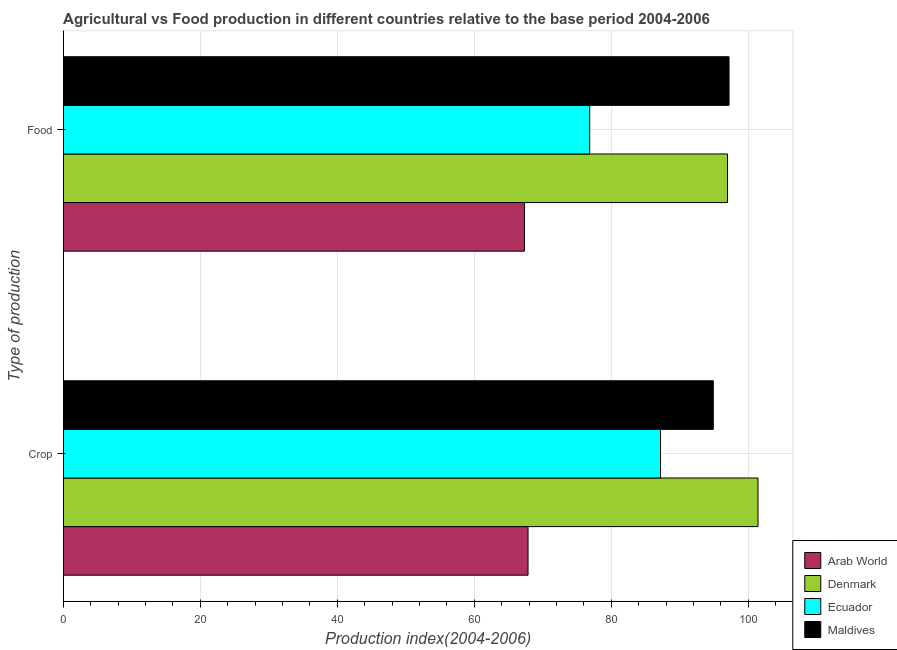Are the number of bars per tick equal to the number of legend labels?
Make the answer very short. Yes. How many bars are there on the 1st tick from the top?
Provide a succinct answer. 4. What is the label of the 2nd group of bars from the top?
Give a very brief answer. Crop. What is the crop production index in Ecuador?
Your answer should be compact. 87.18. Across all countries, what is the maximum crop production index?
Your answer should be very brief. 101.41. Across all countries, what is the minimum food production index?
Your answer should be very brief. 67.32. In which country was the food production index maximum?
Your answer should be very brief. Maldives. In which country was the crop production index minimum?
Provide a short and direct response. Arab World. What is the total food production index in the graph?
Offer a very short reply. 338.29. What is the difference between the crop production index in Arab World and that in Maldives?
Give a very brief answer. -27.04. What is the difference between the crop production index in Arab World and the food production index in Maldives?
Your answer should be compact. -29.34. What is the average crop production index per country?
Keep it short and to the point. 87.83. What is the difference between the crop production index and food production index in Denmark?
Make the answer very short. 4.46. What is the ratio of the food production index in Ecuador to that in Maldives?
Offer a very short reply. 0.79. Is the crop production index in Denmark less than that in Ecuador?
Make the answer very short. No. What does the 2nd bar from the top in Food represents?
Offer a very short reply. Ecuador. What does the 2nd bar from the bottom in Food represents?
Ensure brevity in your answer.  Denmark. How many bars are there?
Make the answer very short. 8. Are all the bars in the graph horizontal?
Your answer should be very brief. Yes. How many countries are there in the graph?
Your answer should be very brief. 4. What is the difference between two consecutive major ticks on the X-axis?
Offer a terse response. 20. Are the values on the major ticks of X-axis written in scientific E-notation?
Your answer should be compact. No. Does the graph contain any zero values?
Make the answer very short. No. How are the legend labels stacked?
Provide a short and direct response. Vertical. What is the title of the graph?
Give a very brief answer. Agricultural vs Food production in different countries relative to the base period 2004-2006. Does "Other small states" appear as one of the legend labels in the graph?
Keep it short and to the point. No. What is the label or title of the X-axis?
Offer a terse response. Production index(2004-2006). What is the label or title of the Y-axis?
Give a very brief answer. Type of production. What is the Production index(2004-2006) of Arab World in Crop?
Offer a terse response. 67.84. What is the Production index(2004-2006) of Denmark in Crop?
Keep it short and to the point. 101.41. What is the Production index(2004-2006) in Ecuador in Crop?
Keep it short and to the point. 87.18. What is the Production index(2004-2006) in Maldives in Crop?
Offer a terse response. 94.88. What is the Production index(2004-2006) of Arab World in Food?
Offer a terse response. 67.32. What is the Production index(2004-2006) in Denmark in Food?
Provide a succinct answer. 96.95. What is the Production index(2004-2006) of Ecuador in Food?
Ensure brevity in your answer.  76.84. What is the Production index(2004-2006) of Maldives in Food?
Your answer should be very brief. 97.18. Across all Type of production, what is the maximum Production index(2004-2006) of Arab World?
Your response must be concise. 67.84. Across all Type of production, what is the maximum Production index(2004-2006) of Denmark?
Ensure brevity in your answer.  101.41. Across all Type of production, what is the maximum Production index(2004-2006) in Ecuador?
Your answer should be very brief. 87.18. Across all Type of production, what is the maximum Production index(2004-2006) of Maldives?
Your response must be concise. 97.18. Across all Type of production, what is the minimum Production index(2004-2006) in Arab World?
Ensure brevity in your answer.  67.32. Across all Type of production, what is the minimum Production index(2004-2006) in Denmark?
Your answer should be very brief. 96.95. Across all Type of production, what is the minimum Production index(2004-2006) of Ecuador?
Your answer should be very brief. 76.84. Across all Type of production, what is the minimum Production index(2004-2006) of Maldives?
Ensure brevity in your answer.  94.88. What is the total Production index(2004-2006) of Arab World in the graph?
Give a very brief answer. 135.17. What is the total Production index(2004-2006) of Denmark in the graph?
Keep it short and to the point. 198.36. What is the total Production index(2004-2006) in Ecuador in the graph?
Your answer should be compact. 164.02. What is the total Production index(2004-2006) in Maldives in the graph?
Provide a succinct answer. 192.06. What is the difference between the Production index(2004-2006) in Arab World in Crop and that in Food?
Your answer should be compact. 0.52. What is the difference between the Production index(2004-2006) in Denmark in Crop and that in Food?
Give a very brief answer. 4.46. What is the difference between the Production index(2004-2006) in Ecuador in Crop and that in Food?
Offer a very short reply. 10.34. What is the difference between the Production index(2004-2006) of Arab World in Crop and the Production index(2004-2006) of Denmark in Food?
Make the answer very short. -29.11. What is the difference between the Production index(2004-2006) of Arab World in Crop and the Production index(2004-2006) of Ecuador in Food?
Offer a very short reply. -9. What is the difference between the Production index(2004-2006) in Arab World in Crop and the Production index(2004-2006) in Maldives in Food?
Provide a succinct answer. -29.34. What is the difference between the Production index(2004-2006) in Denmark in Crop and the Production index(2004-2006) in Ecuador in Food?
Keep it short and to the point. 24.57. What is the difference between the Production index(2004-2006) of Denmark in Crop and the Production index(2004-2006) of Maldives in Food?
Your answer should be compact. 4.23. What is the average Production index(2004-2006) in Arab World per Type of production?
Provide a short and direct response. 67.58. What is the average Production index(2004-2006) of Denmark per Type of production?
Give a very brief answer. 99.18. What is the average Production index(2004-2006) in Ecuador per Type of production?
Ensure brevity in your answer.  82.01. What is the average Production index(2004-2006) in Maldives per Type of production?
Keep it short and to the point. 96.03. What is the difference between the Production index(2004-2006) of Arab World and Production index(2004-2006) of Denmark in Crop?
Give a very brief answer. -33.57. What is the difference between the Production index(2004-2006) of Arab World and Production index(2004-2006) of Ecuador in Crop?
Your response must be concise. -19.34. What is the difference between the Production index(2004-2006) of Arab World and Production index(2004-2006) of Maldives in Crop?
Provide a short and direct response. -27.04. What is the difference between the Production index(2004-2006) of Denmark and Production index(2004-2006) of Ecuador in Crop?
Ensure brevity in your answer.  14.23. What is the difference between the Production index(2004-2006) in Denmark and Production index(2004-2006) in Maldives in Crop?
Your answer should be very brief. 6.53. What is the difference between the Production index(2004-2006) in Arab World and Production index(2004-2006) in Denmark in Food?
Your response must be concise. -29.63. What is the difference between the Production index(2004-2006) in Arab World and Production index(2004-2006) in Ecuador in Food?
Keep it short and to the point. -9.52. What is the difference between the Production index(2004-2006) of Arab World and Production index(2004-2006) of Maldives in Food?
Your response must be concise. -29.86. What is the difference between the Production index(2004-2006) of Denmark and Production index(2004-2006) of Ecuador in Food?
Provide a short and direct response. 20.11. What is the difference between the Production index(2004-2006) in Denmark and Production index(2004-2006) in Maldives in Food?
Make the answer very short. -0.23. What is the difference between the Production index(2004-2006) of Ecuador and Production index(2004-2006) of Maldives in Food?
Offer a terse response. -20.34. What is the ratio of the Production index(2004-2006) in Arab World in Crop to that in Food?
Give a very brief answer. 1.01. What is the ratio of the Production index(2004-2006) in Denmark in Crop to that in Food?
Offer a very short reply. 1.05. What is the ratio of the Production index(2004-2006) in Ecuador in Crop to that in Food?
Make the answer very short. 1.13. What is the ratio of the Production index(2004-2006) of Maldives in Crop to that in Food?
Make the answer very short. 0.98. What is the difference between the highest and the second highest Production index(2004-2006) in Arab World?
Offer a very short reply. 0.52. What is the difference between the highest and the second highest Production index(2004-2006) of Denmark?
Provide a succinct answer. 4.46. What is the difference between the highest and the second highest Production index(2004-2006) of Ecuador?
Your answer should be compact. 10.34. What is the difference between the highest and the lowest Production index(2004-2006) in Arab World?
Offer a very short reply. 0.52. What is the difference between the highest and the lowest Production index(2004-2006) of Denmark?
Offer a terse response. 4.46. What is the difference between the highest and the lowest Production index(2004-2006) in Ecuador?
Ensure brevity in your answer.  10.34. What is the difference between the highest and the lowest Production index(2004-2006) of Maldives?
Ensure brevity in your answer.  2.3. 